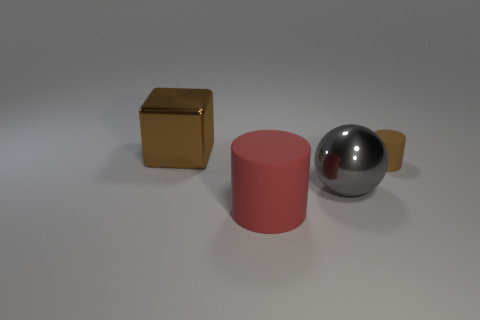There is a large block that is the same color as the small matte cylinder; what material is it?
Make the answer very short. Metal. Are there any blocks that have the same color as the tiny rubber thing?
Offer a very short reply. Yes. There is a thing that is both right of the large rubber object and on the left side of the small brown rubber object; what shape is it?
Keep it short and to the point. Sphere. What number of big blocks have the same material as the red object?
Give a very brief answer. 0. Are there fewer big gray balls that are on the right side of the big gray metallic thing than metal cubes in front of the brown shiny object?
Provide a succinct answer. No. What material is the small brown thing to the right of the big shiny thing that is in front of the tiny thing behind the red rubber thing made of?
Your response must be concise. Rubber. There is a thing that is both in front of the tiny brown cylinder and behind the red matte cylinder; what is its size?
Provide a succinct answer. Large. How many balls are either big gray metal objects or brown matte things?
Provide a short and direct response. 1. There is a metallic object that is the same size as the shiny sphere; what color is it?
Offer a very short reply. Brown. Are there any other things that have the same shape as the big brown shiny thing?
Offer a terse response. No. 